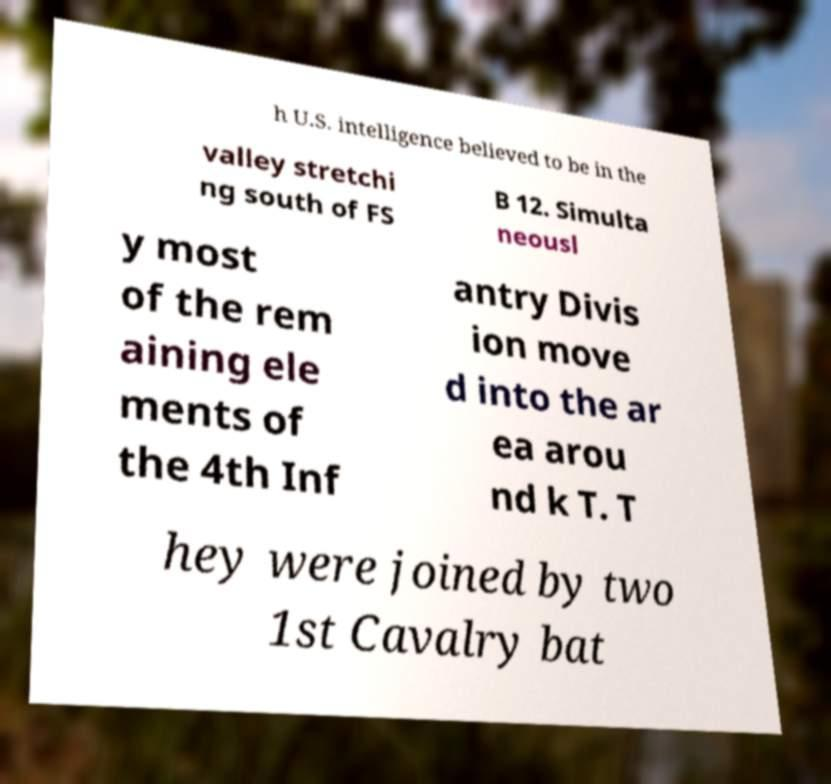Could you assist in decoding the text presented in this image and type it out clearly? h U.S. intelligence believed to be in the valley stretchi ng south of FS B 12. Simulta neousl y most of the rem aining ele ments of the 4th Inf antry Divis ion move d into the ar ea arou nd k T. T hey were joined by two 1st Cavalry bat 